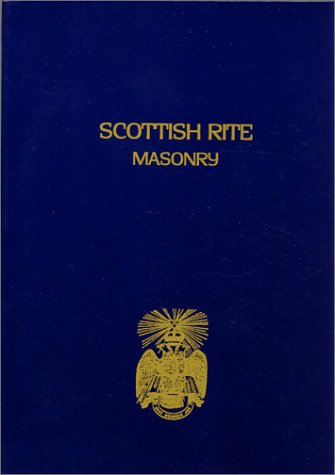What is the title of this book? The title of the book, as prominently displayed on its cover, is 'Scottish Rite Masonry Vol.2'. 